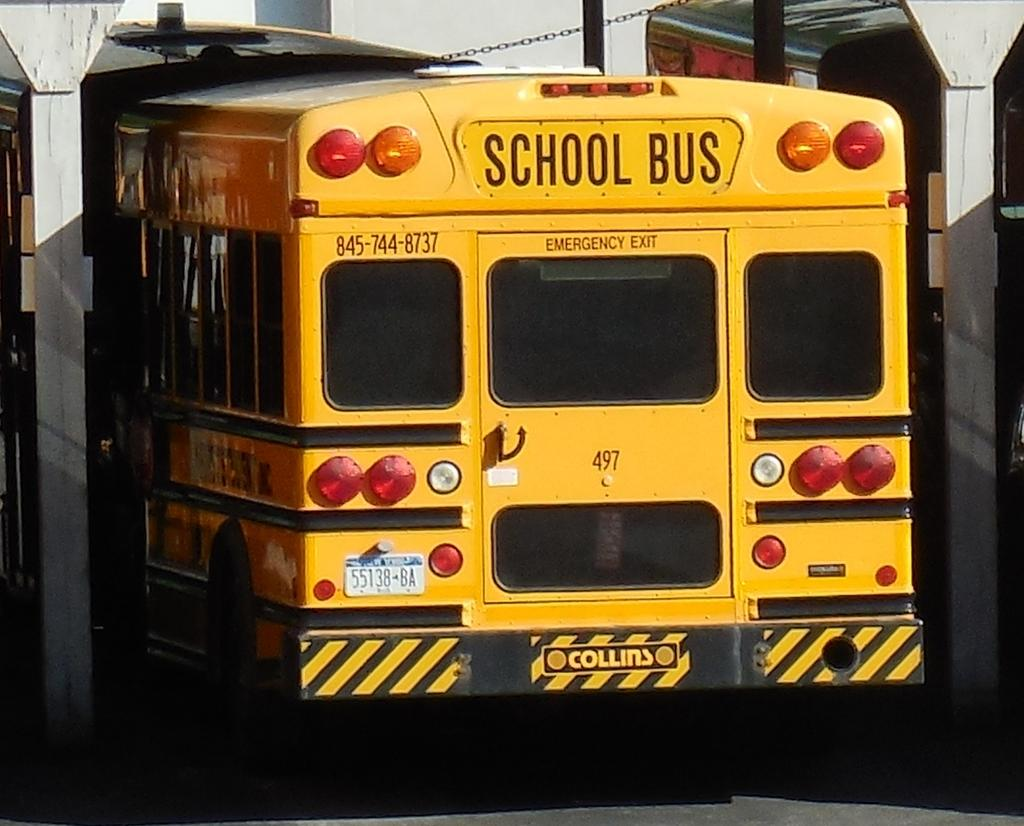What type of vehicle is in the image? There is a yellow color bus in the image. What is the status of the bus in the image? The bus appears to be parked on the ground. What can be seen in the background of the image? There is a wall, pillars, and metal rods visible in the background of the image. Can you hear the snails making any sounds in the image? There are no snails present in the image, so it is not possible to hear any sounds they might make. 